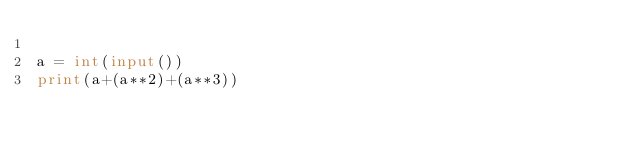<code> <loc_0><loc_0><loc_500><loc_500><_Python_>
a = int(input())
print(a+(a**2)+(a**3))
</code> 